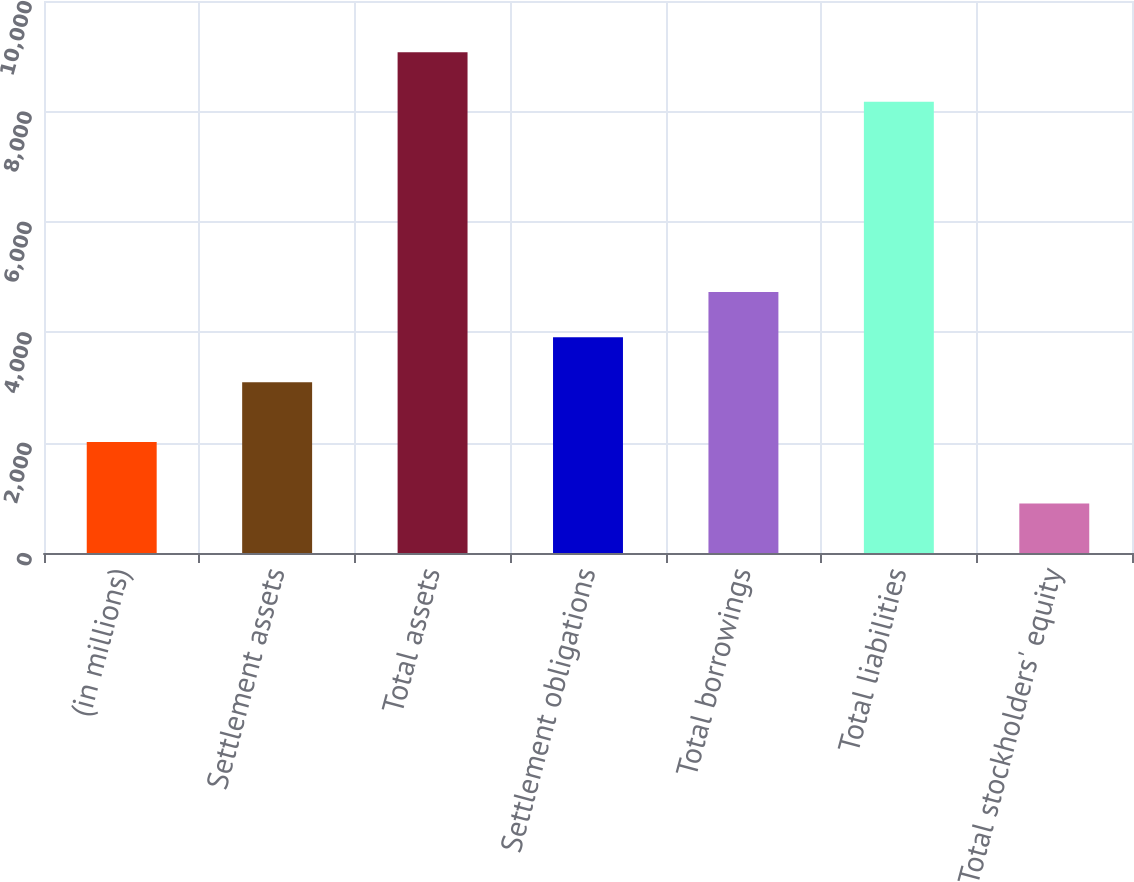Convert chart to OTSL. <chart><loc_0><loc_0><loc_500><loc_500><bar_chart><fcel>(in millions)<fcel>Settlement assets<fcel>Total assets<fcel>Settlement obligations<fcel>Total borrowings<fcel>Total liabilities<fcel>Total stockholders' equity<nl><fcel>2011<fcel>3091.2<fcel>9069.9<fcel>3908.71<fcel>4726.22<fcel>8175.1<fcel>894.8<nl></chart> 